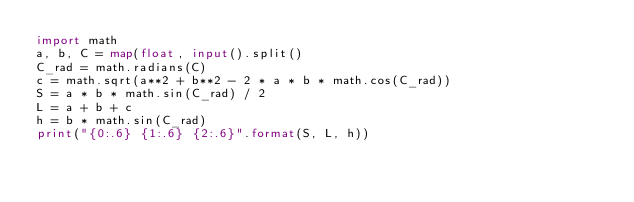<code> <loc_0><loc_0><loc_500><loc_500><_Python_>import math
a, b, C = map(float, input().split()
C_rad = math.radians(C)
c = math.sqrt(a**2 + b**2 - 2 * a * b * math.cos(C_rad))
S = a * b * math.sin(C_rad) / 2
L = a + b + c
h = b * math.sin(C_rad)
print("{0:.6} {1:.6} {2:.6}".format(S, L, h))</code> 